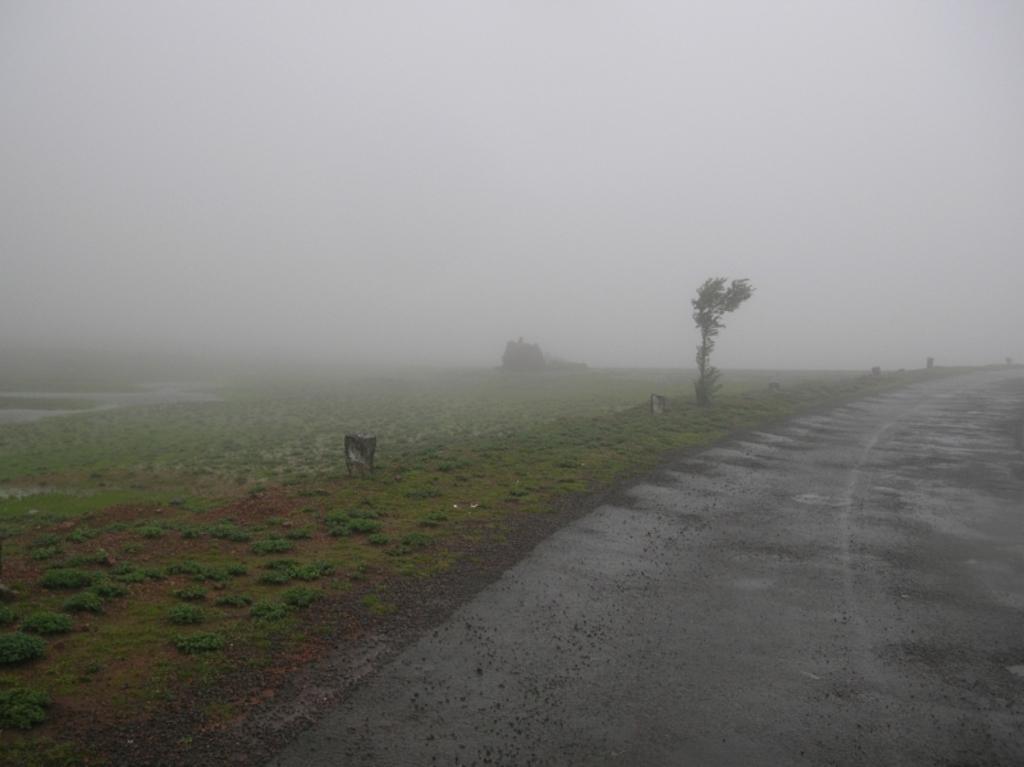Please provide a concise description of this image. In this picture I can see green grass. I can see the road. I can see clouds in the sky. 